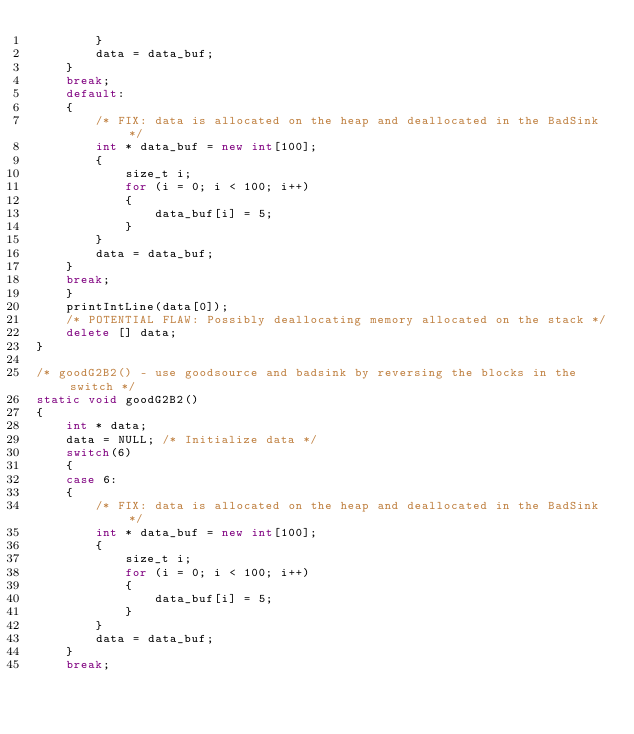Convert code to text. <code><loc_0><loc_0><loc_500><loc_500><_C++_>        }
        data = data_buf;
    }
    break;
    default:
    {
        /* FIX: data is allocated on the heap and deallocated in the BadSink */
        int * data_buf = new int[100];
        {
            size_t i;
            for (i = 0; i < 100; i++)
            {
                data_buf[i] = 5;
            }
        }
        data = data_buf;
    }
    break;
    }
    printIntLine(data[0]);
    /* POTENTIAL FLAW: Possibly deallocating memory allocated on the stack */
    delete [] data;
}

/* goodG2B2() - use goodsource and badsink by reversing the blocks in the switch */
static void goodG2B2()
{
    int * data;
    data = NULL; /* Initialize data */
    switch(6)
    {
    case 6:
    {
        /* FIX: data is allocated on the heap and deallocated in the BadSink */
        int * data_buf = new int[100];
        {
            size_t i;
            for (i = 0; i < 100; i++)
            {
                data_buf[i] = 5;
            }
        }
        data = data_buf;
    }
    break;</code> 